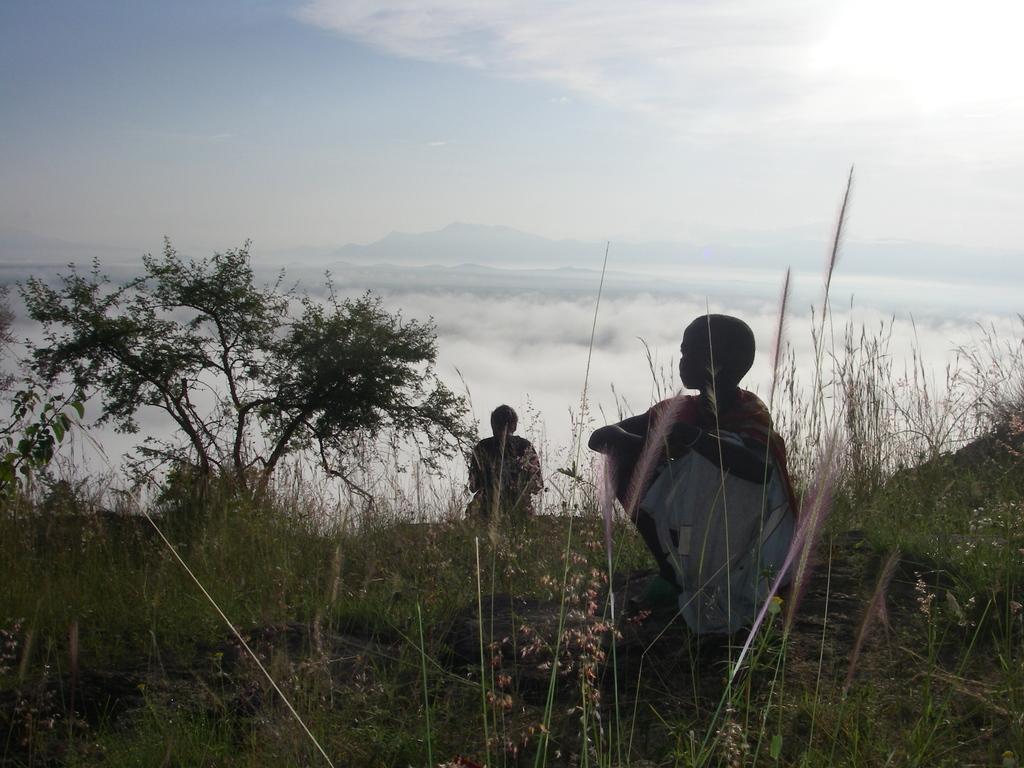In one or two sentences, can you explain what this image depicts? In this picture I can observe two members on the land. There is some grass on the ground. On the left side I can observe a tree. In the background there are clouds in the sky. 